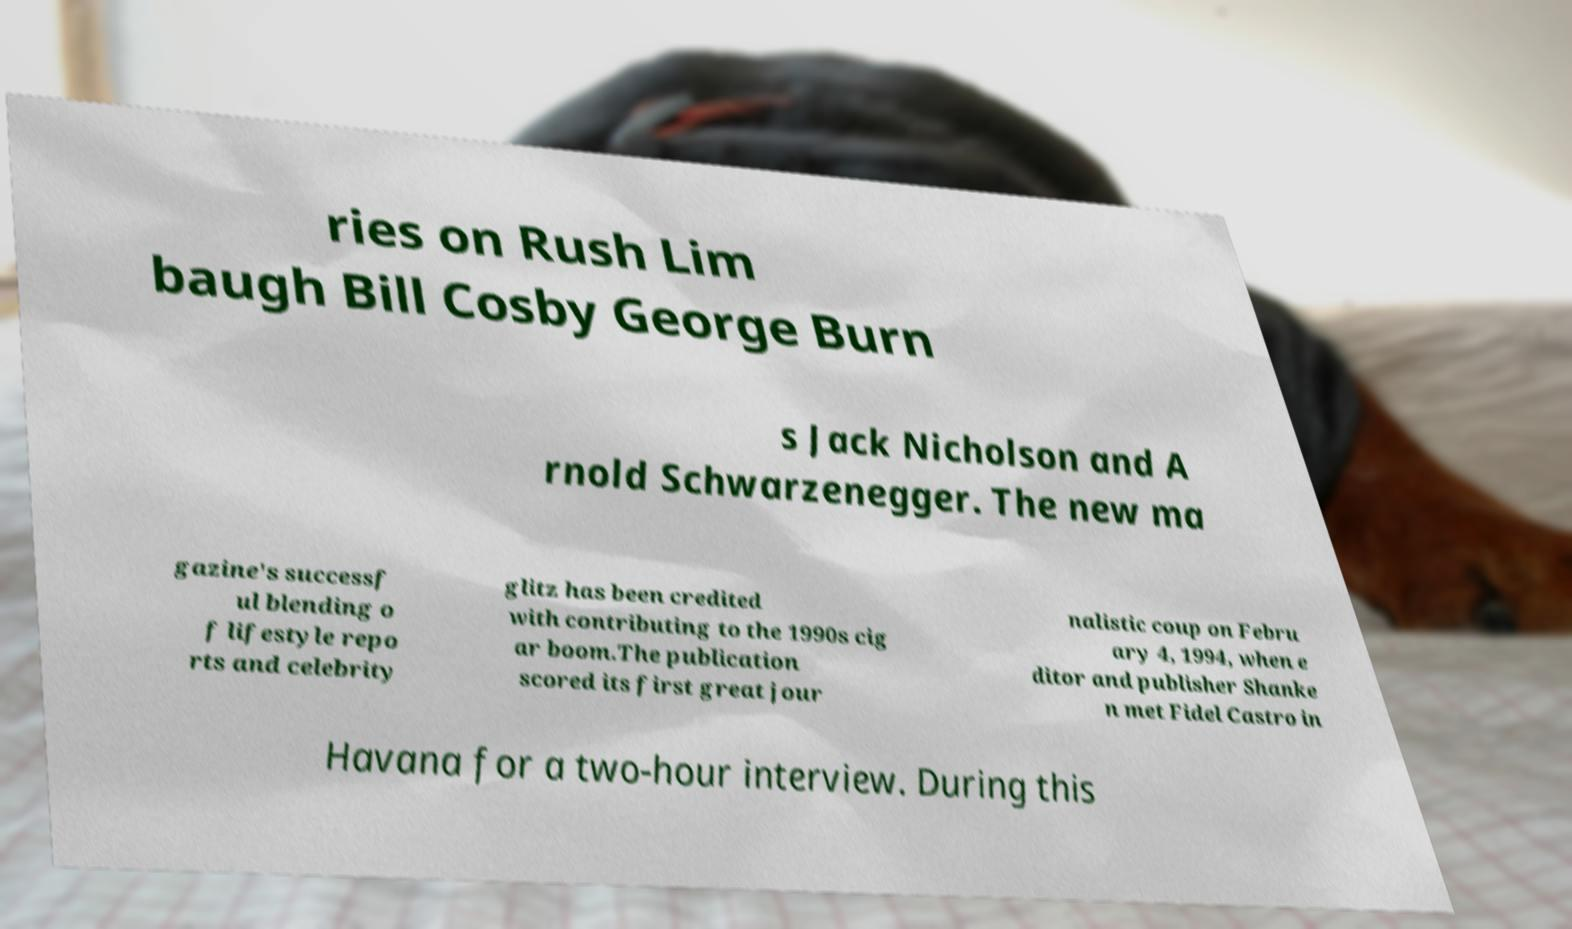Could you extract and type out the text from this image? ries on Rush Lim baugh Bill Cosby George Burn s Jack Nicholson and A rnold Schwarzenegger. The new ma gazine's successf ul blending o f lifestyle repo rts and celebrity glitz has been credited with contributing to the 1990s cig ar boom.The publication scored its first great jour nalistic coup on Febru ary 4, 1994, when e ditor and publisher Shanke n met Fidel Castro in Havana for a two-hour interview. During this 